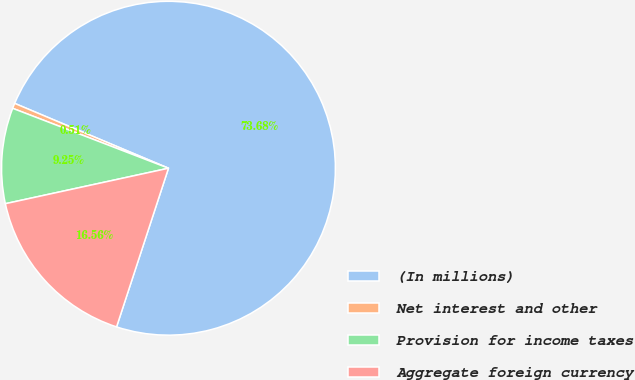Convert chart. <chart><loc_0><loc_0><loc_500><loc_500><pie_chart><fcel>(In millions)<fcel>Net interest and other<fcel>Provision for income taxes<fcel>Aggregate foreign currency<nl><fcel>73.68%<fcel>0.51%<fcel>9.25%<fcel>16.56%<nl></chart> 